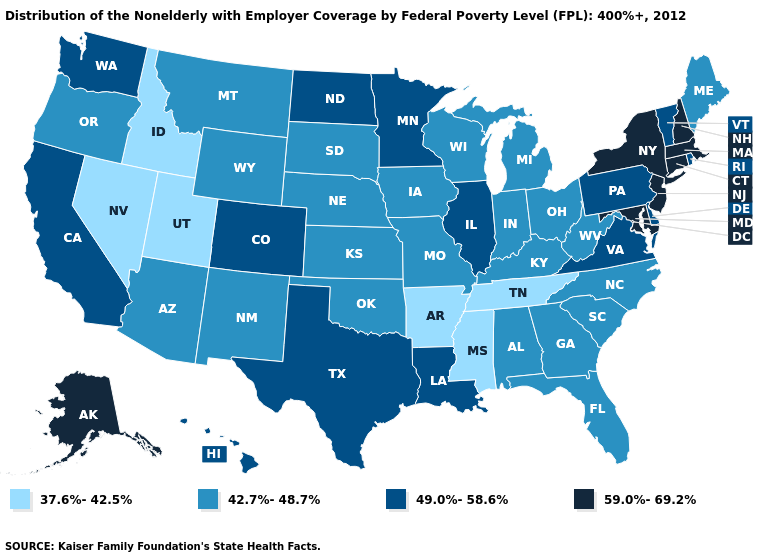What is the lowest value in the USA?
Concise answer only. 37.6%-42.5%. Among the states that border South Dakota , does Wyoming have the highest value?
Give a very brief answer. No. Which states hav the highest value in the MidWest?
Answer briefly. Illinois, Minnesota, North Dakota. Which states have the highest value in the USA?
Quick response, please. Alaska, Connecticut, Maryland, Massachusetts, New Hampshire, New Jersey, New York. Is the legend a continuous bar?
Short answer required. No. What is the lowest value in the USA?
Be succinct. 37.6%-42.5%. Which states have the lowest value in the MidWest?
Write a very short answer. Indiana, Iowa, Kansas, Michigan, Missouri, Nebraska, Ohio, South Dakota, Wisconsin. What is the lowest value in states that border Missouri?
Be succinct. 37.6%-42.5%. Name the states that have a value in the range 49.0%-58.6%?
Concise answer only. California, Colorado, Delaware, Hawaii, Illinois, Louisiana, Minnesota, North Dakota, Pennsylvania, Rhode Island, Texas, Vermont, Virginia, Washington. Does Utah have the lowest value in the West?
Answer briefly. Yes. What is the highest value in the USA?
Answer briefly. 59.0%-69.2%. Among the states that border Wisconsin , does Illinois have the lowest value?
Keep it brief. No. Name the states that have a value in the range 37.6%-42.5%?
Concise answer only. Arkansas, Idaho, Mississippi, Nevada, Tennessee, Utah. Among the states that border Maryland , which have the lowest value?
Short answer required. West Virginia. 